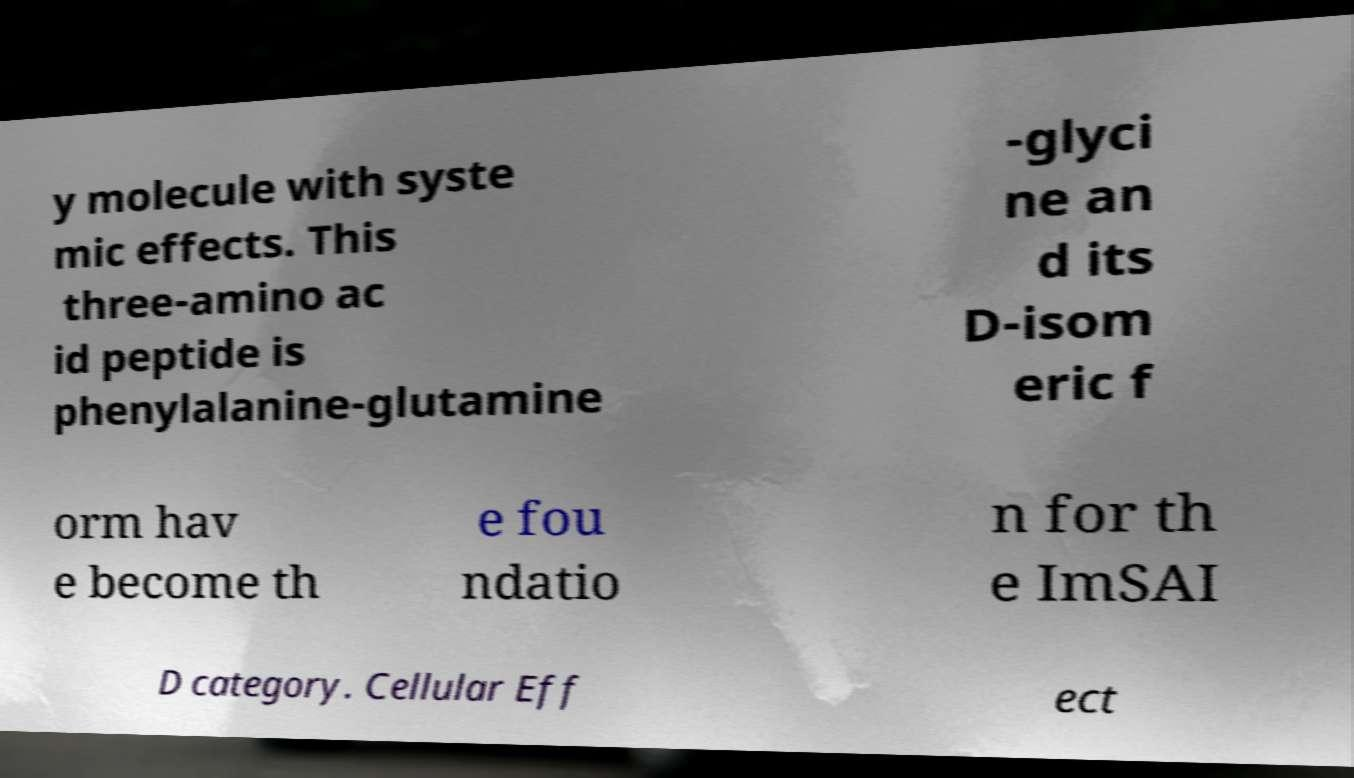Could you assist in decoding the text presented in this image and type it out clearly? y molecule with syste mic effects. This three-amino ac id peptide is phenylalanine-glutamine -glyci ne an d its D-isom eric f orm hav e become th e fou ndatio n for th e ImSAI D category. Cellular Eff ect 